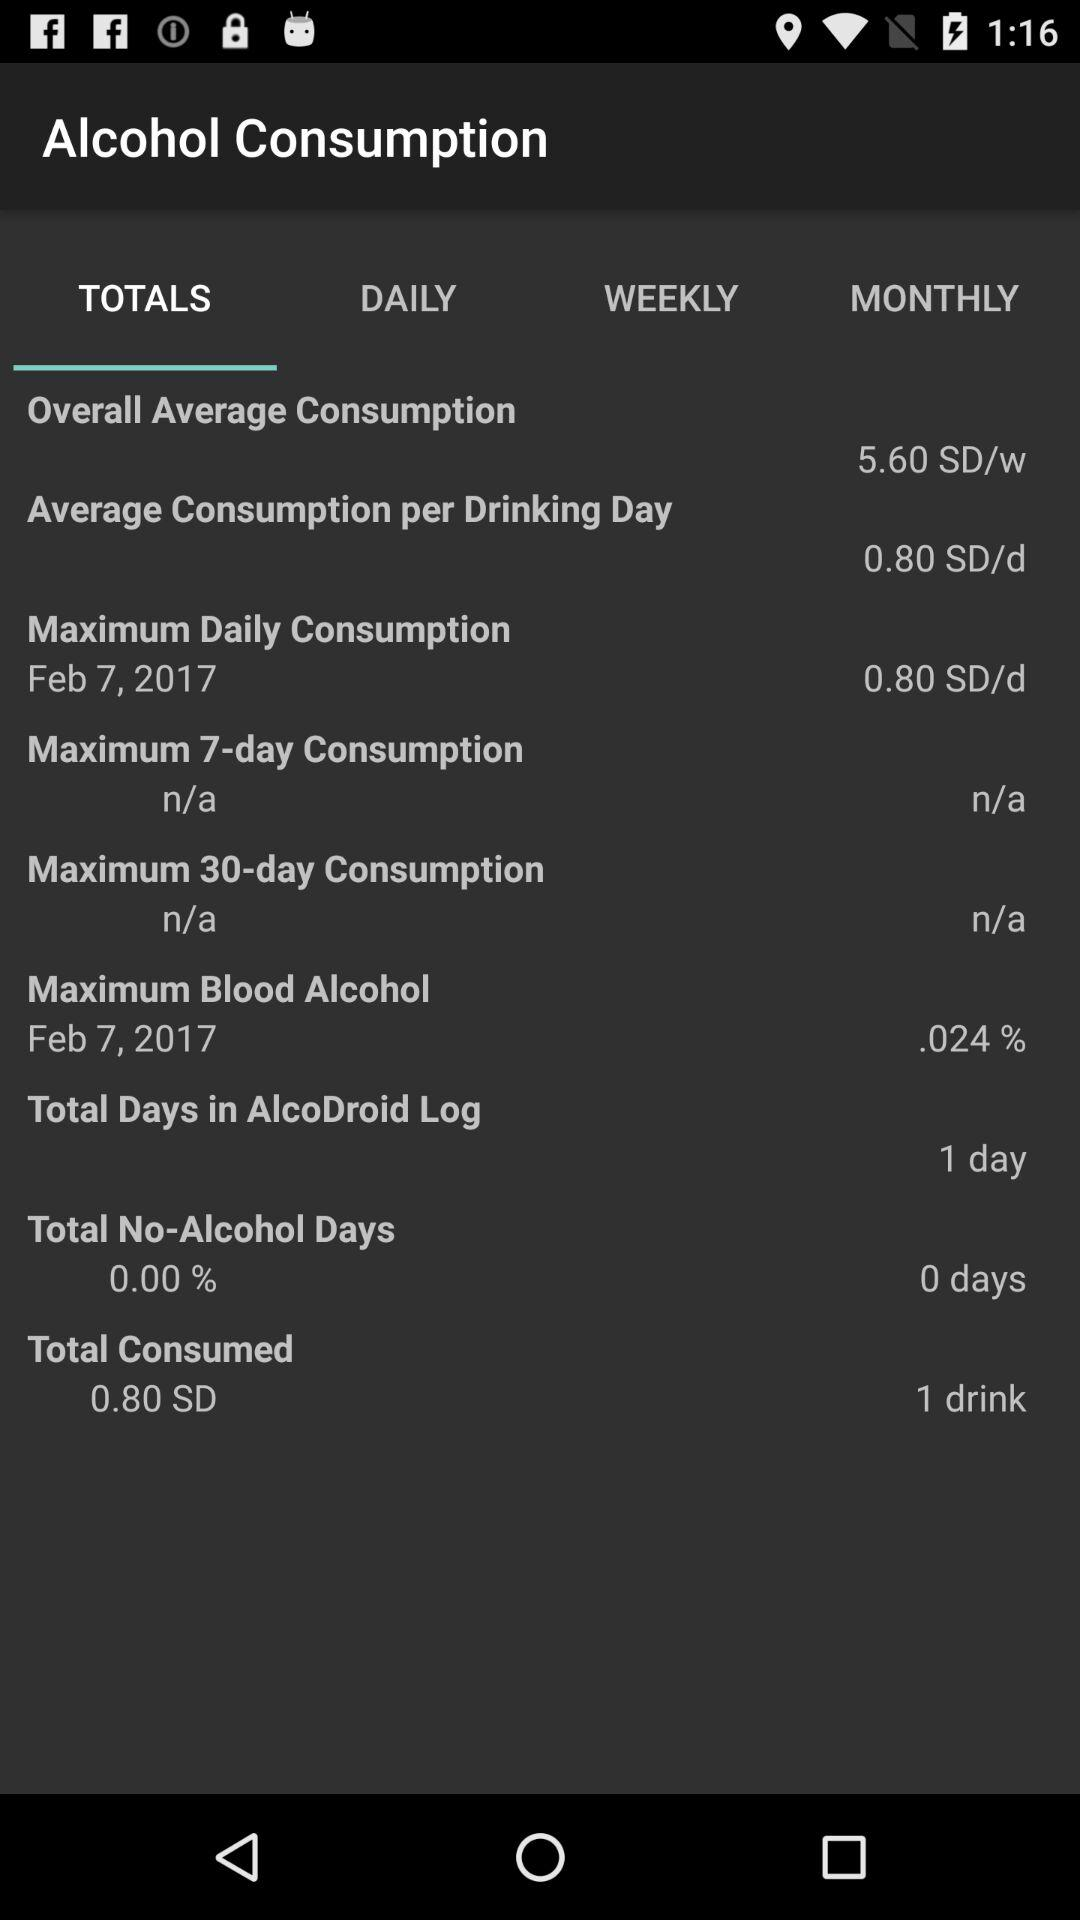What is the percentage of maximum blood alcohol content? The percentage of maximum blood alcohol content is 0.024. 